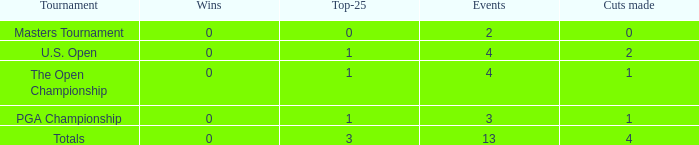How many cuts made in the tournament he played 13 times? None. 